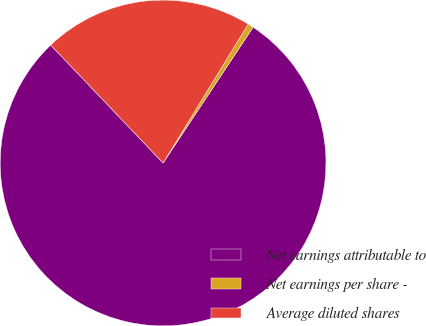<chart> <loc_0><loc_0><loc_500><loc_500><pie_chart><fcel>Net earnings attributable to<fcel>Net earnings per share -<fcel>Average diluted shares<nl><fcel>78.56%<fcel>0.57%<fcel>20.87%<nl></chart> 